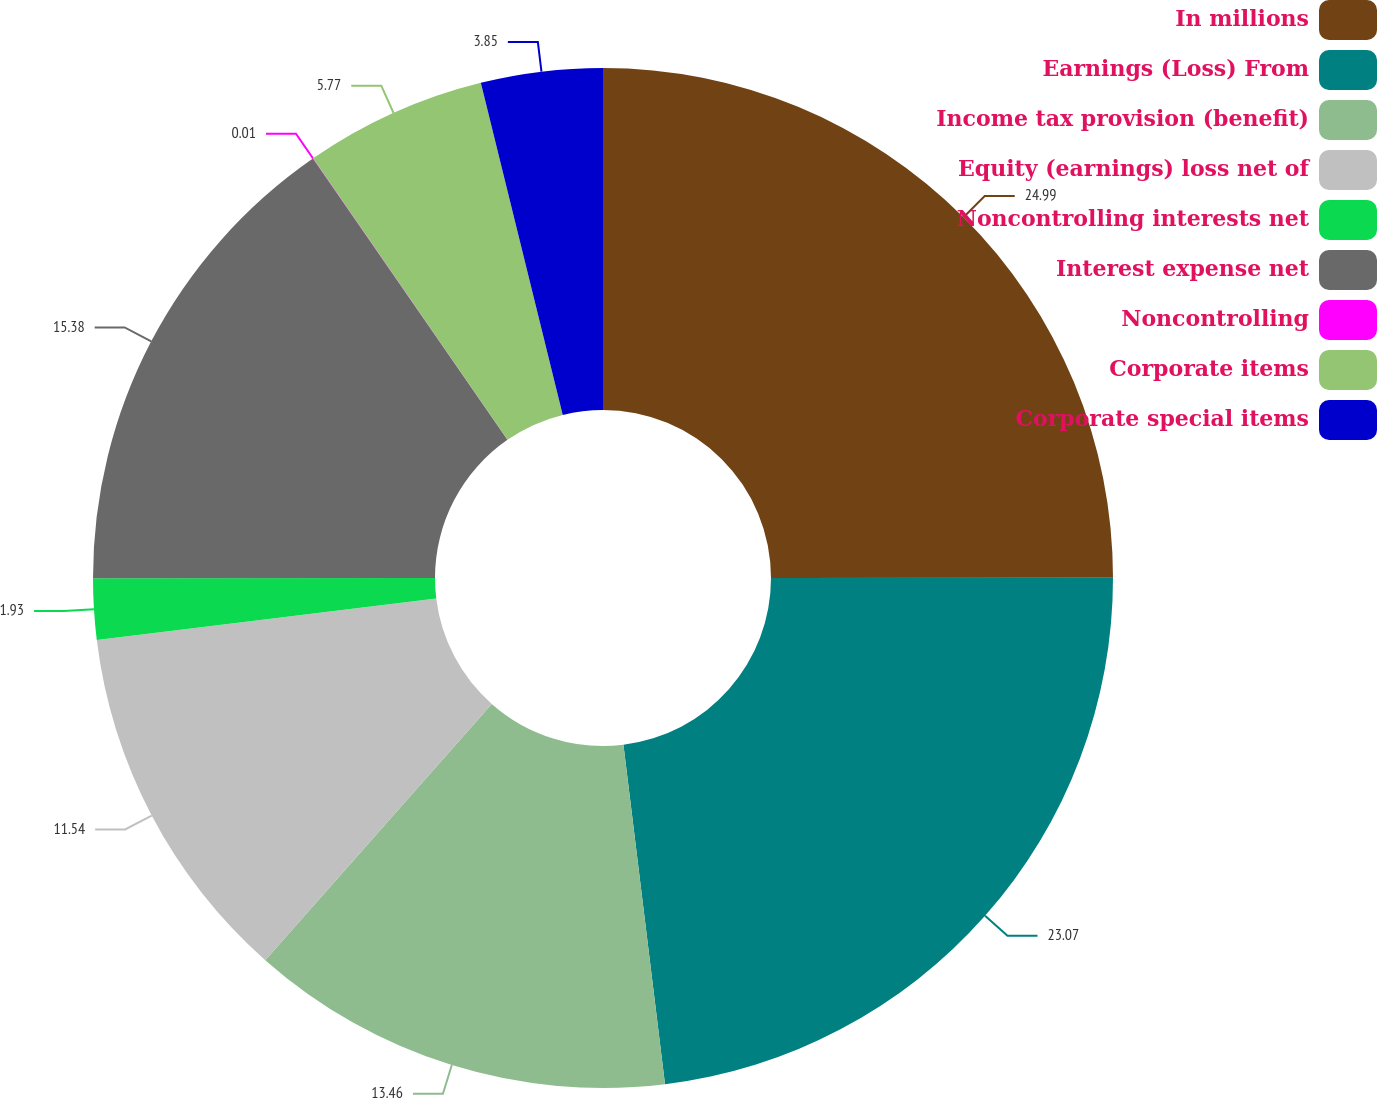Convert chart. <chart><loc_0><loc_0><loc_500><loc_500><pie_chart><fcel>In millions<fcel>Earnings (Loss) From<fcel>Income tax provision (benefit)<fcel>Equity (earnings) loss net of<fcel>Noncontrolling interests net<fcel>Interest expense net<fcel>Noncontrolling<fcel>Corporate items<fcel>Corporate special items<nl><fcel>24.99%<fcel>23.07%<fcel>13.46%<fcel>11.54%<fcel>1.93%<fcel>15.38%<fcel>0.01%<fcel>5.77%<fcel>3.85%<nl></chart> 